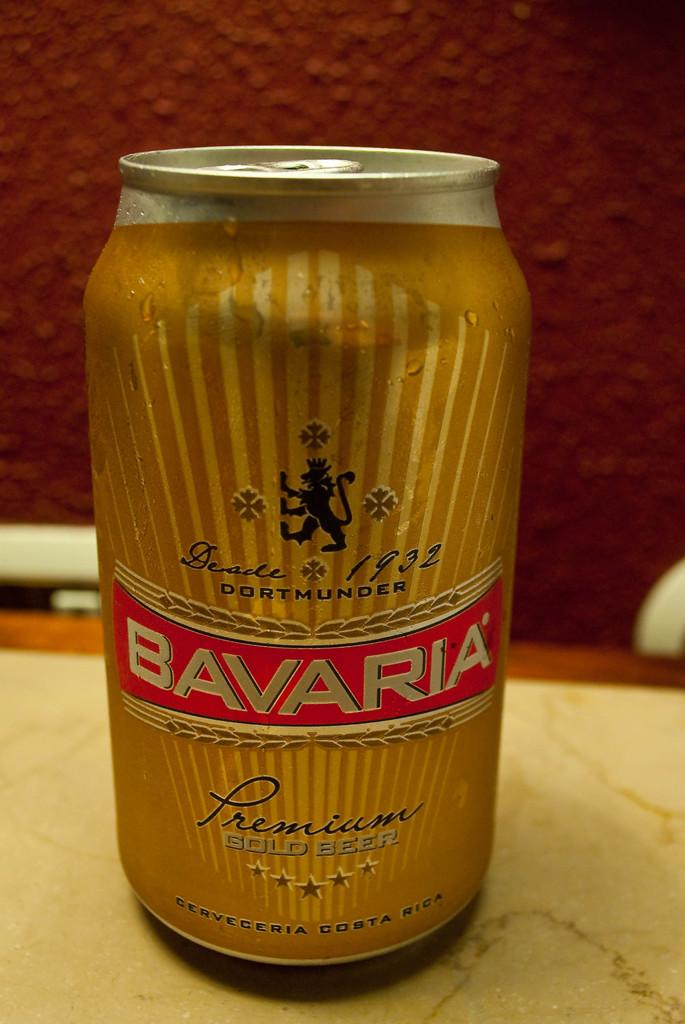Provide a one-sentence caption for the provided image. A simple image of a yellow can of Bavaria Lager. 